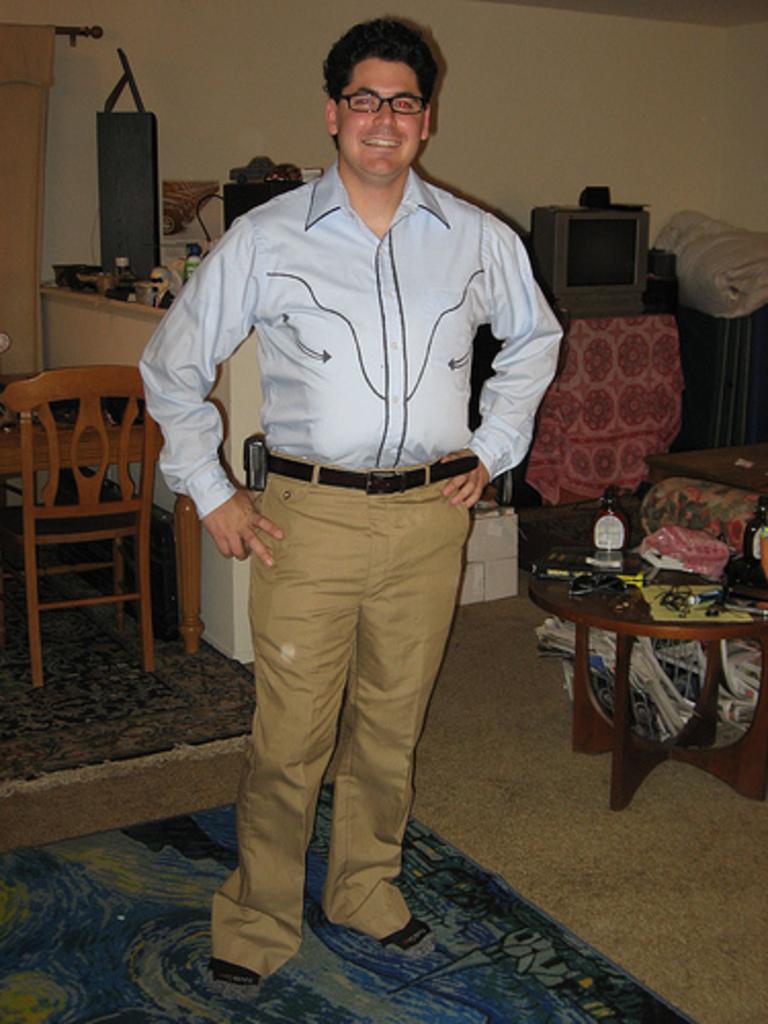How would you summarize this image in a sentence or two? This image is taken inside a room. In the middle of the image a man is standing. At the bottom of the image there is a floor with mat. At the right side of the image there is a television on the table, a sofa and a coffee table with many things on it. In the left side of the image there is a dining table and chair. At the background there is a wall and a curtain. 